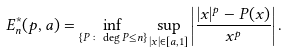Convert formula to latex. <formula><loc_0><loc_0><loc_500><loc_500>E ^ { * } _ { n } ( p , a ) = \inf _ { \{ P \colon \deg P \leq n \} } \sup _ { | x | \in [ a , 1 ] } \left | \frac { | x | ^ { p } - P ( x ) } { x ^ { p } } \right | .</formula> 